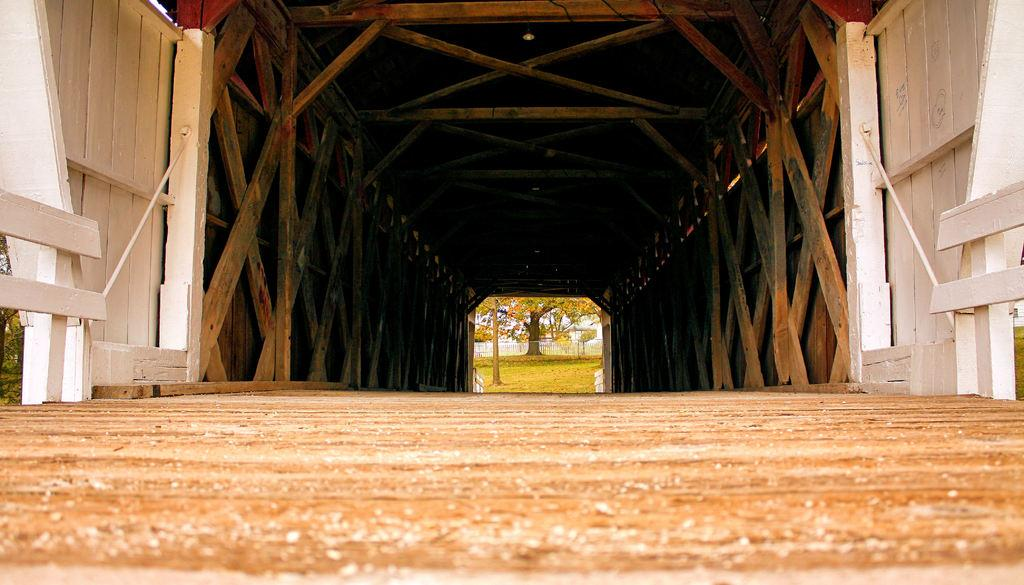What type of material is used for the bars in the image? The wooden bars in the image are made of wood. What type of vegetation is present in the image? There are trees in the image. What can be seen beneath the trees and wooden bars in the image? The ground is visible in the image. Where is the bee located in the image? There is no bee present in the image. What type of land is visible in the image? The image does not show any specific type of land; it only shows wooden bars, trees, and the ground. 